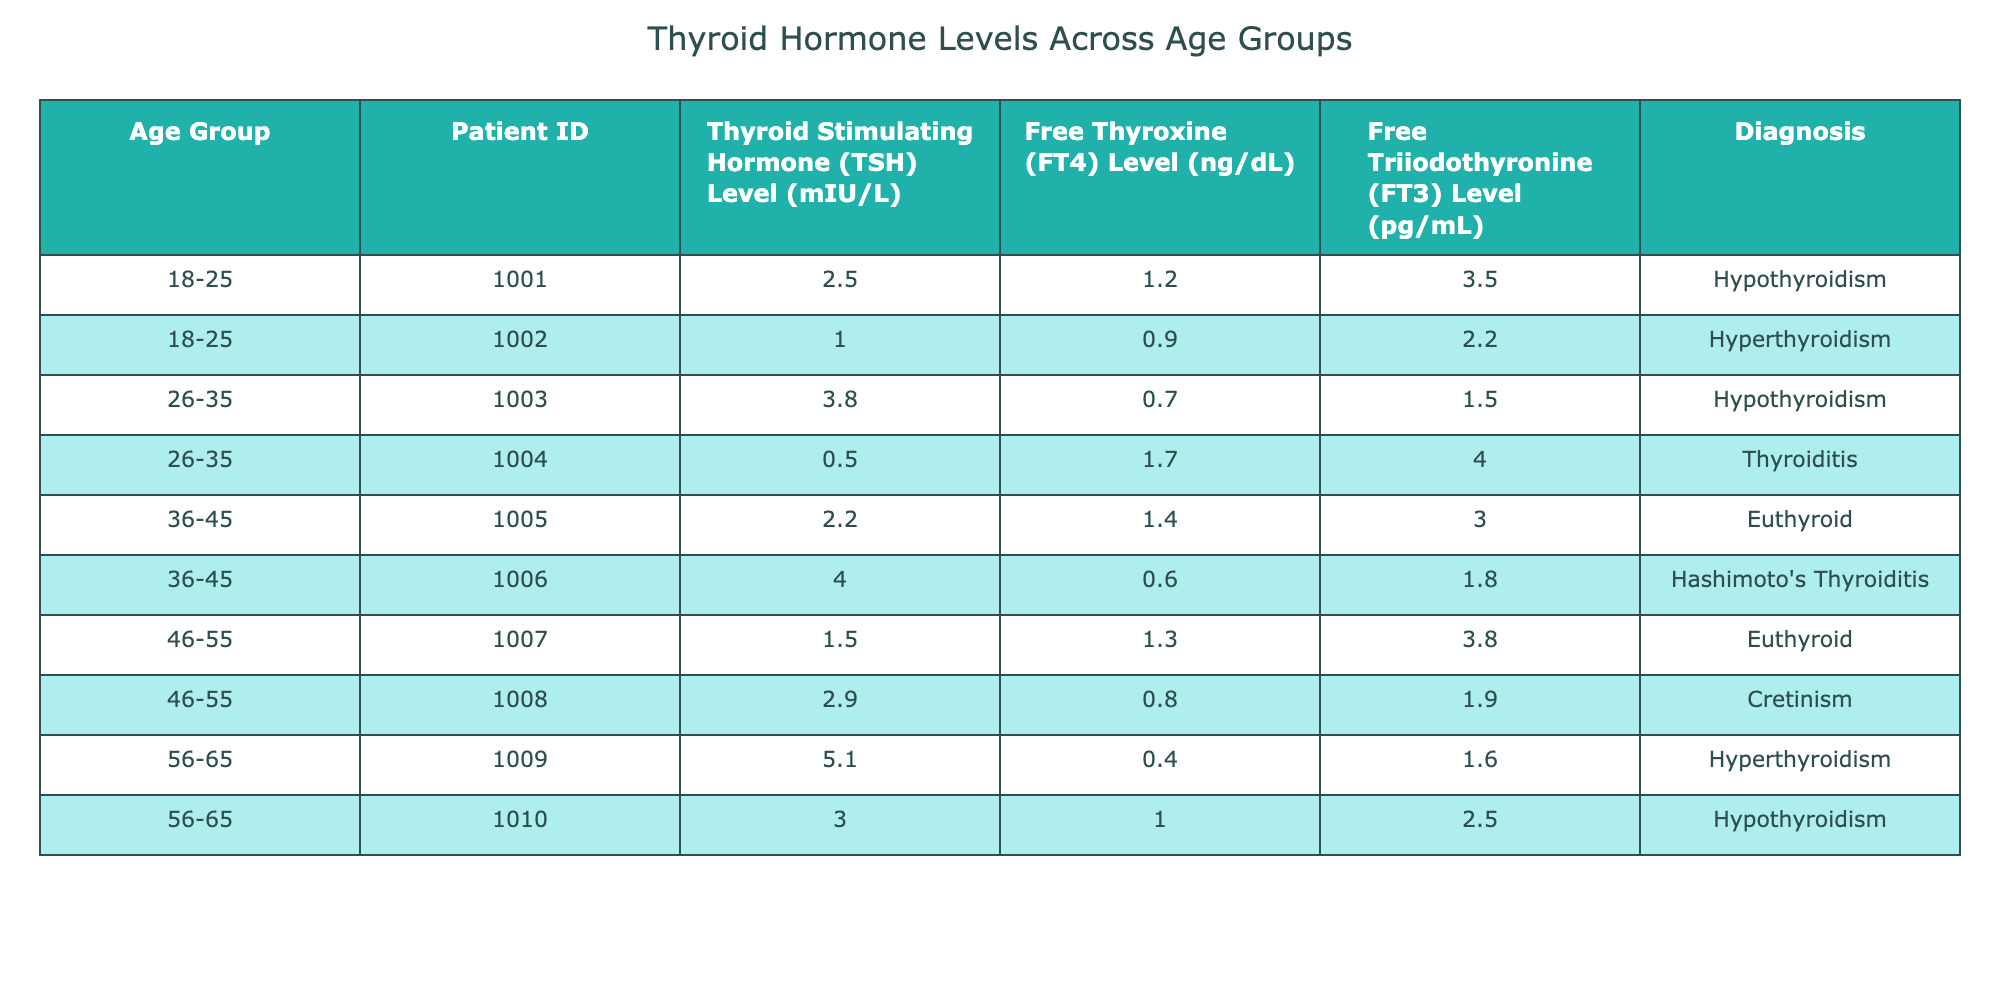What is the TSH level of the patient diagnosed with Hyperthyroidism in the 18-25 age group? The patient ID 1002 is in the 18-25 age group and diagnosed with Hyperthyroidism, with a TSH level listed as 1.0 mIU/L.
Answer: 1.0 mIU/L How many patients in the 56-65 age group have a TSH level greater than 4.0 mIU/L? There are two patients in the 56-65 age group: one with a TSH level of 5.1 mIU/L and another with 3.0 mIU/L. Only the first patient exceeds 4.0 mIU/L, therefore, the count is one.
Answer: 1 What is the average FT4 level for patients diagnosed with Hypothyroidism across all age groups? There are two patients with Hypothyroidism (IDs 1001 and 1010). Their FT4 levels are 1.2 ng/dL and 1.0 ng/dL. The average is (1.2 + 1.0) / 2 = 1.1 ng/dL.
Answer: 1.1 ng/dL Is it true that all patients in the 46-55 age group are diagnosed with Euthyroid? In the 46-55 age group, there are two patients (IDs 1007 and 1008). One is diagnosed as Euthyroid and the other as Cretinism. Therefore, the statement is false.
Answer: No What's the maximum Free Triiodothyronine (FT3) level recorded in the table? The FT3 levels are 3.5, 2.2, 1.5, 4.0, 3.0, 1.8, 3.8, 1.9, 1.6, and 2.5 for the corresponding patients. The maximum FT3 level is 4.0 pg/mL.
Answer: 4.0 pg/mL What is the difference in TSH levels between the youngest and oldest patient groups? The youngest group (18-25) has a maximum TSH level of 2.5 mIU/L, while the oldest group (56-65) has a maximum of 5.1 mIU/L. The difference is 5.1 - 2.5 = 2.6 mIU/L.
Answer: 2.6 mIU/L 